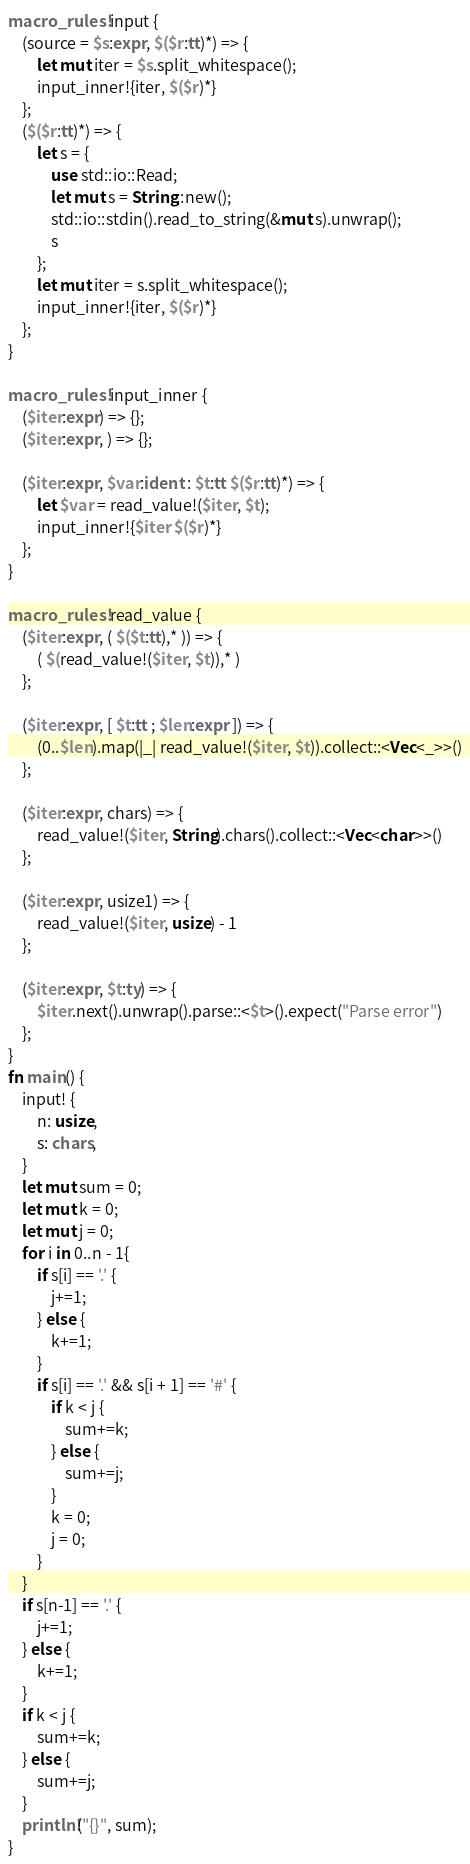<code> <loc_0><loc_0><loc_500><loc_500><_Rust_>macro_rules! input {
    (source = $s:expr, $($r:tt)*) => {
        let mut iter = $s.split_whitespace();
        input_inner!{iter, $($r)*}
    };
    ($($r:tt)*) => {
        let s = {
            use std::io::Read;
            let mut s = String::new();
            std::io::stdin().read_to_string(&mut s).unwrap();
            s
        };
        let mut iter = s.split_whitespace();
        input_inner!{iter, $($r)*}
    };
}

macro_rules! input_inner {
    ($iter:expr) => {};
    ($iter:expr, ) => {};

    ($iter:expr, $var:ident : $t:tt $($r:tt)*) => {
        let $var = read_value!($iter, $t);
        input_inner!{$iter $($r)*}
    };
}

macro_rules! read_value {
    ($iter:expr, ( $($t:tt),* )) => {
        ( $(read_value!($iter, $t)),* )
    };

    ($iter:expr, [ $t:tt ; $len:expr ]) => {
        (0..$len).map(|_| read_value!($iter, $t)).collect::<Vec<_>>()
    };

    ($iter:expr, chars) => {
        read_value!($iter, String).chars().collect::<Vec<char>>()
    };

    ($iter:expr, usize1) => {
        read_value!($iter, usize) - 1
    };

    ($iter:expr, $t:ty) => {
        $iter.next().unwrap().parse::<$t>().expect("Parse error")
    };
}
fn main() {
    input! {
        n: usize,
        s: chars, 
    }
    let mut sum = 0;
    let mut k = 0;
    let mut j = 0;
    for i in 0..n - 1{
        if s[i] == '.' {
            j+=1;
        } else {
            k+=1;
        } 
        if s[i] == '.' && s[i + 1] == '#' {
            if k < j {
                sum+=k;
            } else {
                sum+=j;
            }
            k = 0;
            j = 0;
        }
    }
    if s[n-1] == '.' {
        j+=1;
    } else {
        k+=1;
    } 
    if k < j {
        sum+=k;
    } else {
        sum+=j;
    }
    println!("{}", sum);
}
</code> 